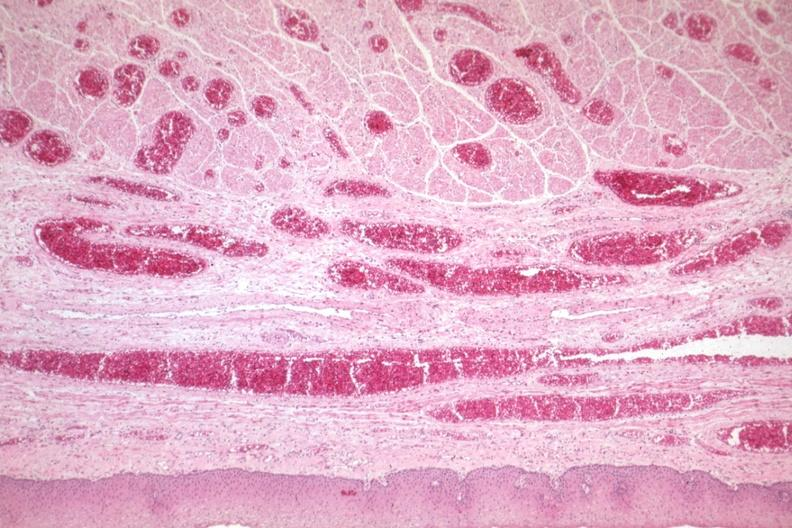what is present?
Answer the question using a single word or phrase. Esophagus 